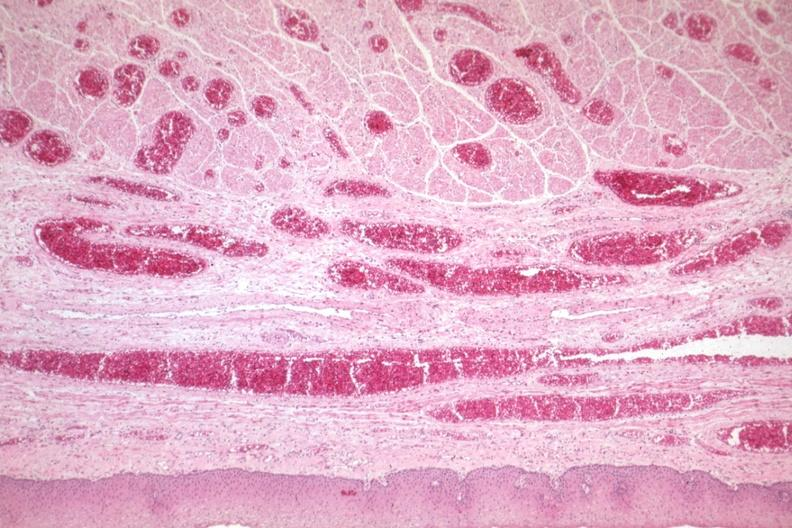what is present?
Answer the question using a single word or phrase. Esophagus 